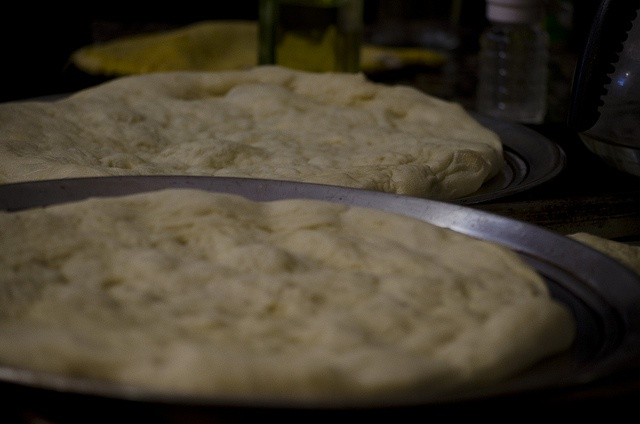Describe the objects in this image and their specific colors. I can see dining table in black and gray tones, pizza in black and gray tones, pizza in black and gray tones, bottle in black and darkgreen tones, and bottle in black and gray tones in this image. 